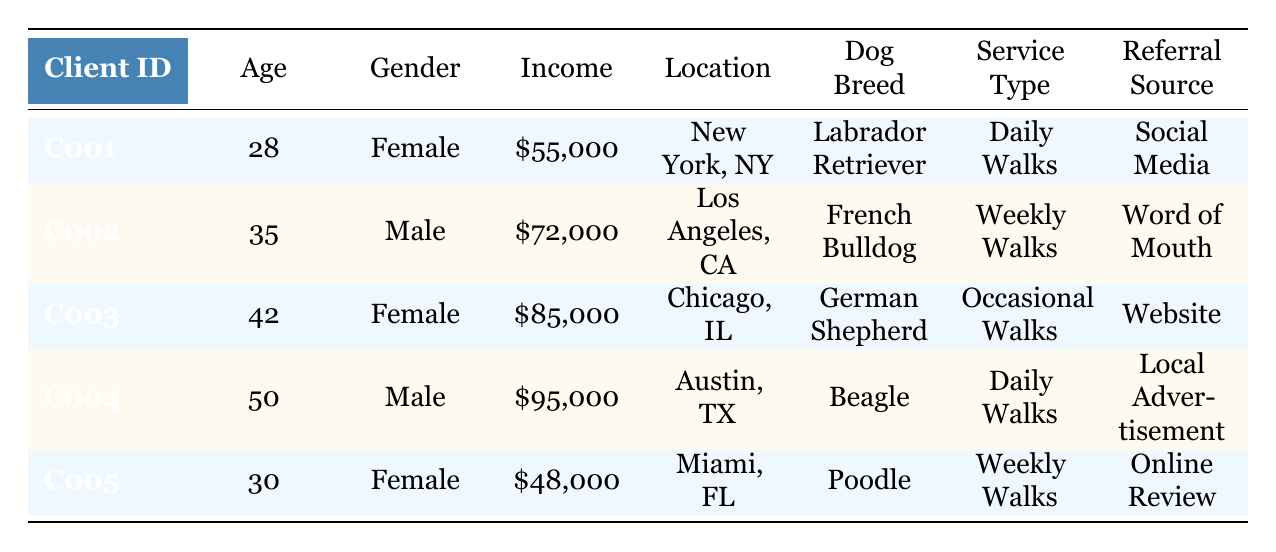What is the age of the client with ID C003? Refer to the 'Age' column in the row matching Client ID C003, which lists the age as 42.
Answer: 42 What is the income of the female client living in Chicago? Locate the row for the female client in Chicago, which corresponds to C003, and find the 'Income' value listed as 85,000.
Answer: 85,000 How many clients use Daily Walks as their service type? Identify the clients with 'Service Type' as Daily Walks. From the table, C001 and C004 correspond to Daily Walks, totaling 2 clients.
Answer: 2 Is there a client who has referred their service through Social Media? Check the 'Referral Source' for each client. C001 is the only one that lists Social Media.
Answer: Yes Which location has the highest income among clients? Review the 'Income' values and corresponding locations. C004 in Austin has the highest income at 95,000 compared to others.
Answer: Austin, TX What is the average age of female clients in the database? The female clients are C001 (28 years) and C003 (42 years). Summing their ages gives 28 + 42 = 70. Dividing by 2 clients, the average age is 70/2 = 35.
Answer: 35 Is the median income of all clients above 70,000? First, list the incomes: 55,000, 72,000, 85,000, 95,000, 48,000. Sorting these gives us 48,000, 55,000, 72,000, 85,000, 95,000. The median (middle value) is 72,000, which is not above 70,000.
Answer: No What percentage of clients owns a Beagle? There is one client, C004, who owns a Beagle out of 5 total clients. Calculating the percentage: (1/5) * 100 = 20%.
Answer: 20% How many clients have a referral source from Word of Mouth and are male? Analyze the data for male clients and their referral sources. C002 is the only male client listed with Word of Mouth, making it 1 client.
Answer: 1 